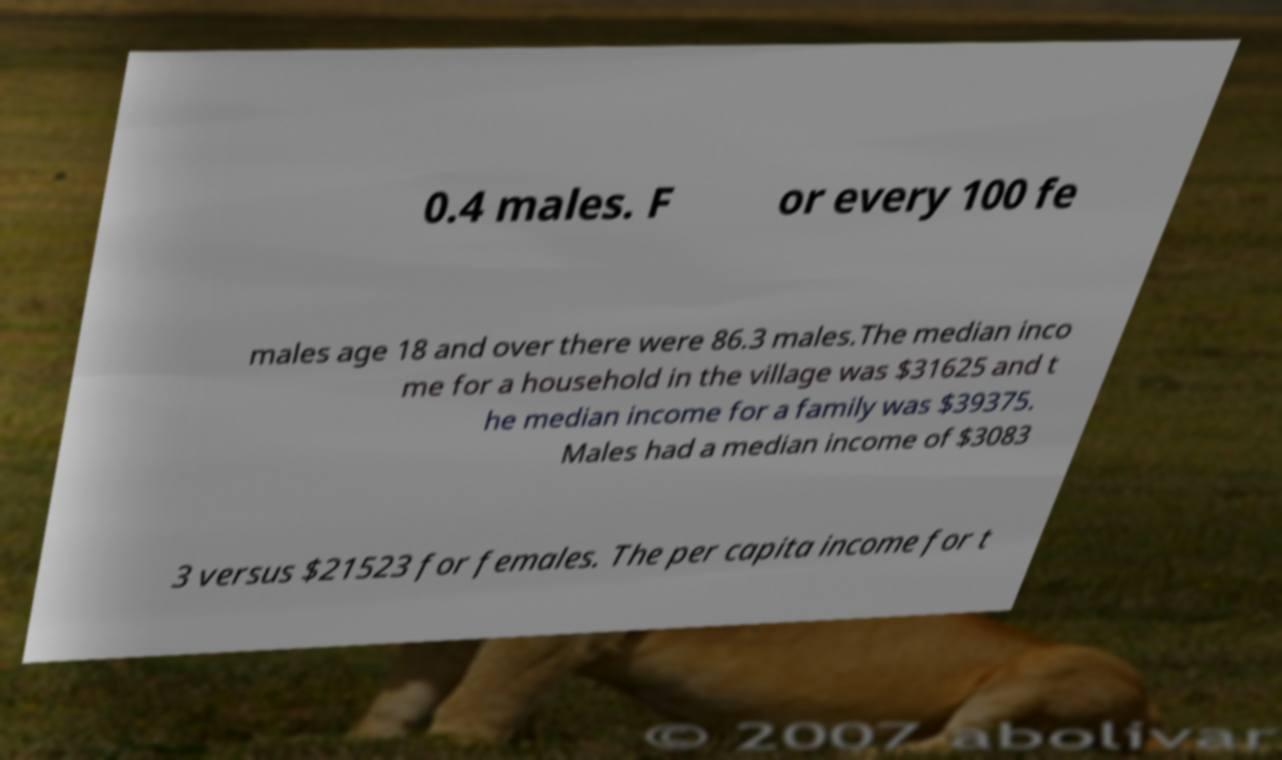Please identify and transcribe the text found in this image. 0.4 males. F or every 100 fe males age 18 and over there were 86.3 males.The median inco me for a household in the village was $31625 and t he median income for a family was $39375. Males had a median income of $3083 3 versus $21523 for females. The per capita income for t 